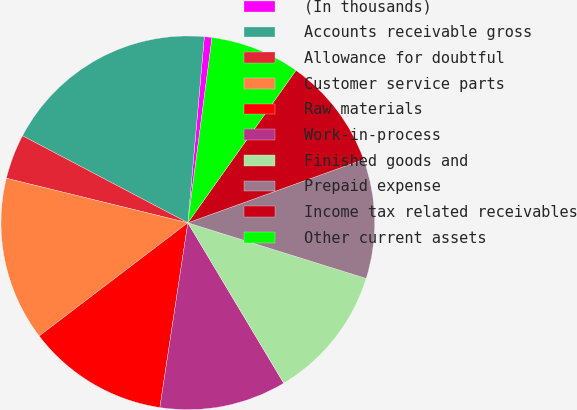Convert chart to OTSL. <chart><loc_0><loc_0><loc_500><loc_500><pie_chart><fcel>(In thousands)<fcel>Accounts receivable gross<fcel>Allowance for doubtful<fcel>Customer service parts<fcel>Raw materials<fcel>Work-in-process<fcel>Finished goods and<fcel>Prepaid expense<fcel>Income tax related receivables<fcel>Other current assets<nl><fcel>0.66%<fcel>18.7%<fcel>3.88%<fcel>14.19%<fcel>12.25%<fcel>10.97%<fcel>11.61%<fcel>10.32%<fcel>9.68%<fcel>7.75%<nl></chart> 